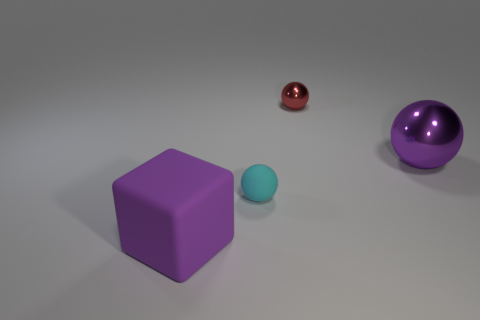Add 4 small shiny things. How many objects exist? 8 Subtract all blue cubes. Subtract all red cylinders. How many cubes are left? 1 Subtract all cubes. How many objects are left? 3 Add 1 big purple matte things. How many big purple matte things are left? 2 Add 2 tiny yellow cubes. How many tiny yellow cubes exist? 2 Subtract 1 purple spheres. How many objects are left? 3 Subtract all purple cubes. Subtract all cyan matte spheres. How many objects are left? 2 